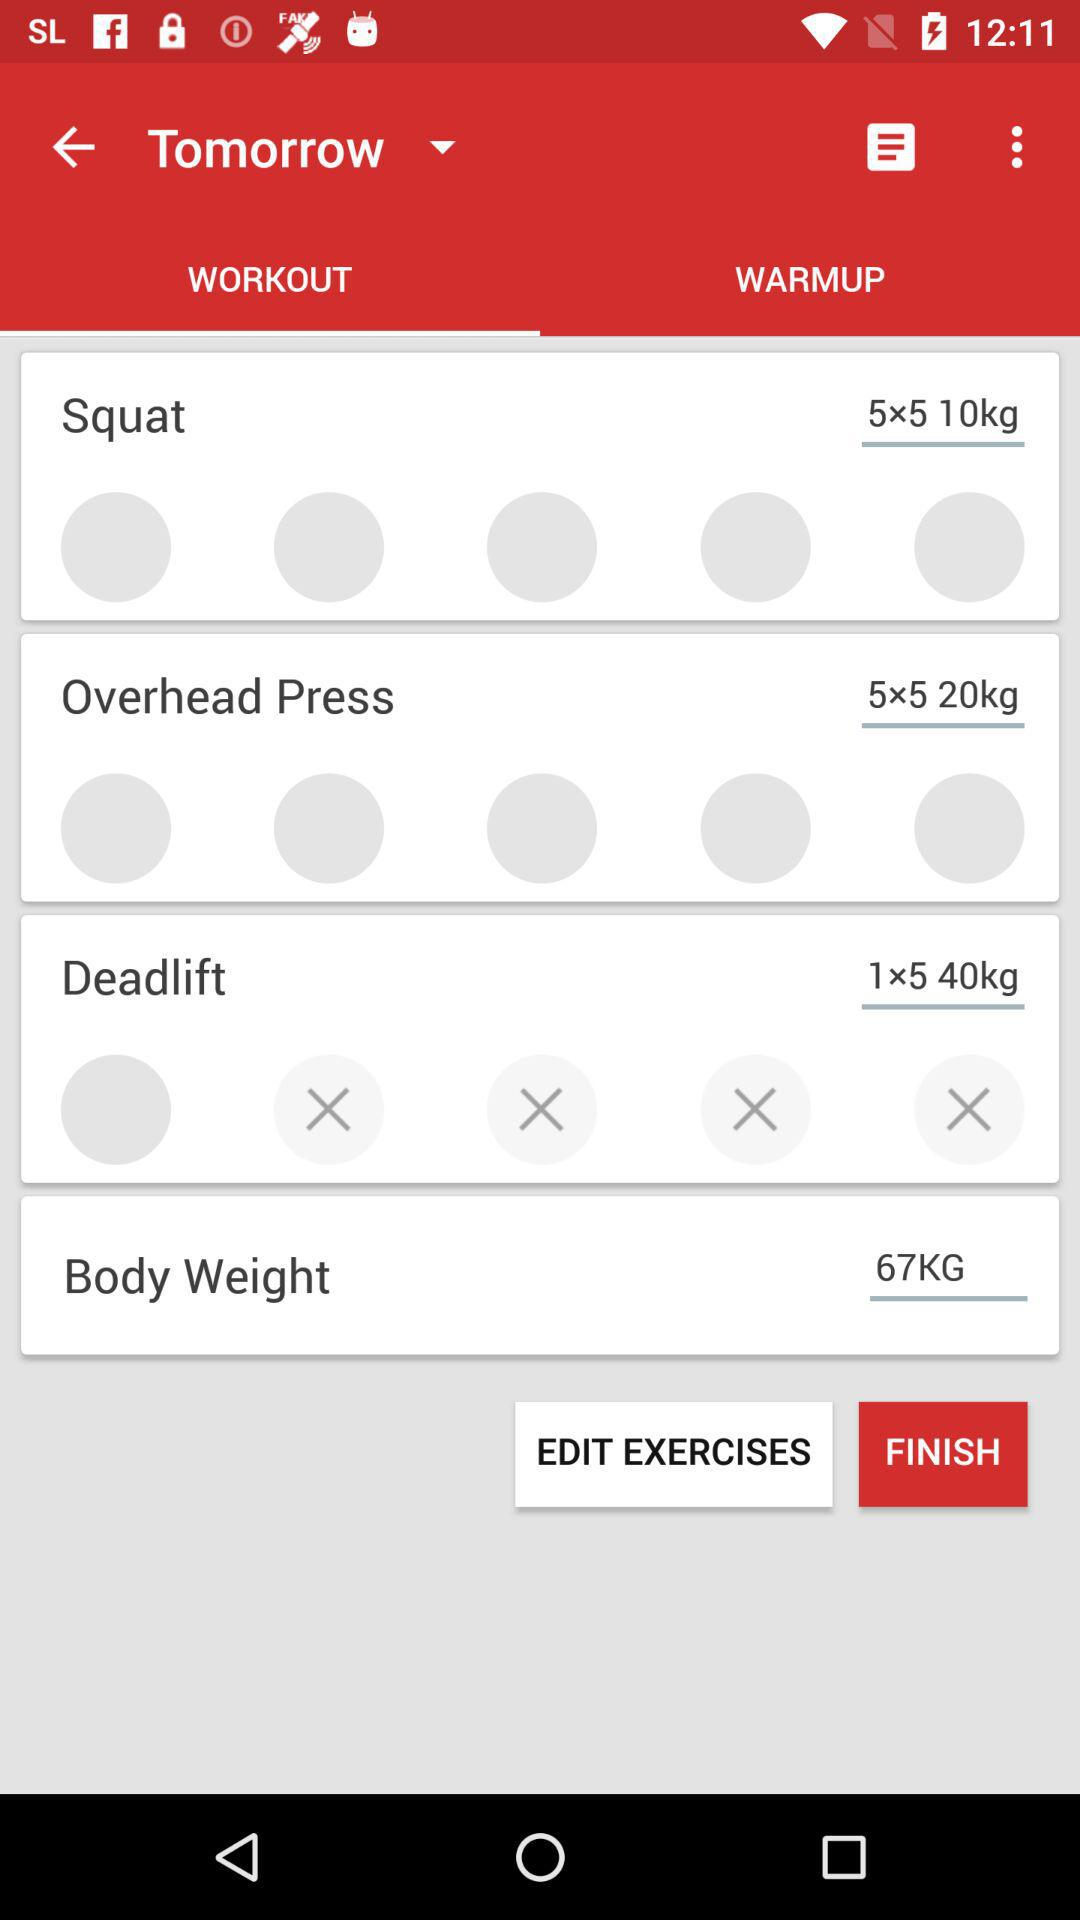How many sets are there for the exercise 'Squat'?
Answer the question using a single word or phrase. 5 